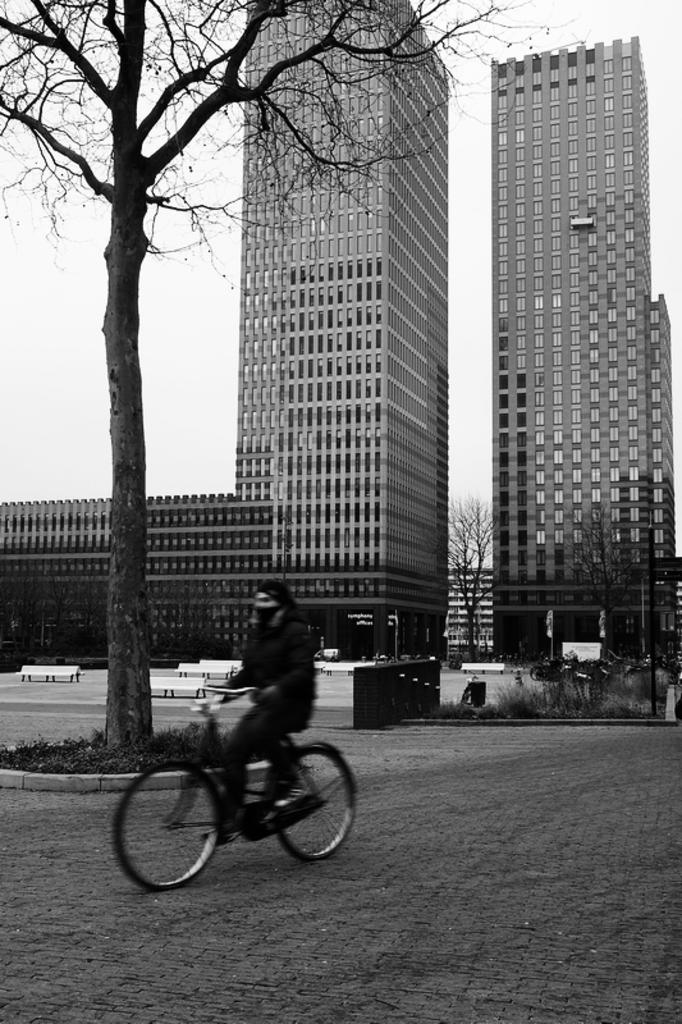What is the person in the image doing? There is a person riding a bicycle on the road in the image. How many buildings can be seen in the image? There are two buildings in the image. What is located to the left side of the image? There is a tree to the left side of the image. What type of vegetation is at the bottom of the tree? There is grass at the bottom of the tree. What type of suit is the person wearing while riding the bicycle? There is no mention of a suit in the image, as the person is riding a bicycle and not wearing any specific clothing. 